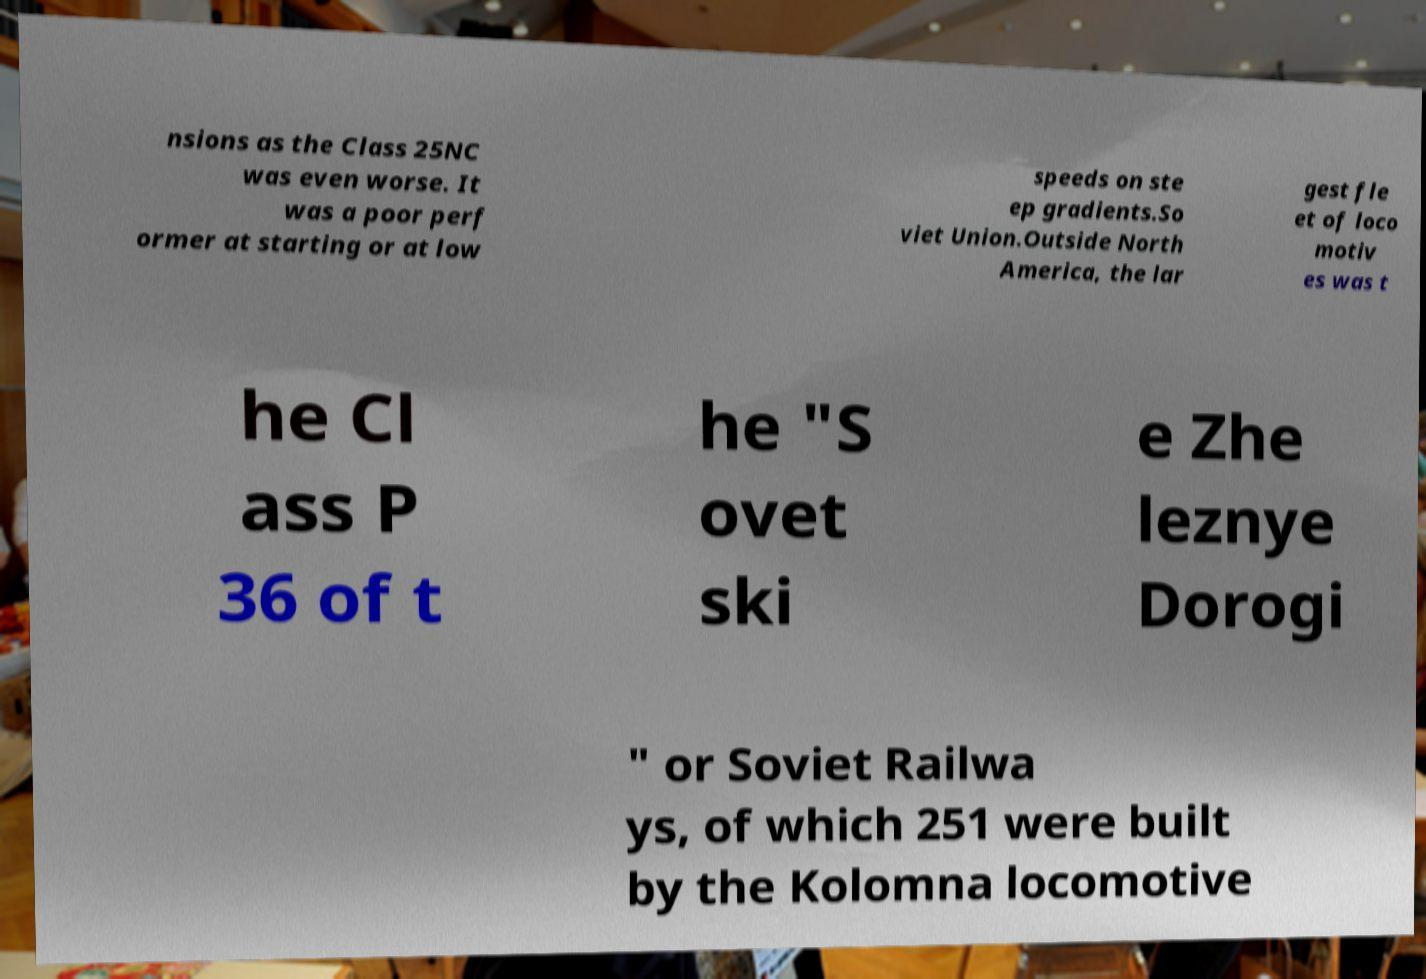Can you accurately transcribe the text from the provided image for me? nsions as the Class 25NC was even worse. It was a poor perf ormer at starting or at low speeds on ste ep gradients.So viet Union.Outside North America, the lar gest fle et of loco motiv es was t he Cl ass P 36 of t he "S ovet ski e Zhe leznye Dorogi " or Soviet Railwa ys, of which 251 were built by the Kolomna locomotive 